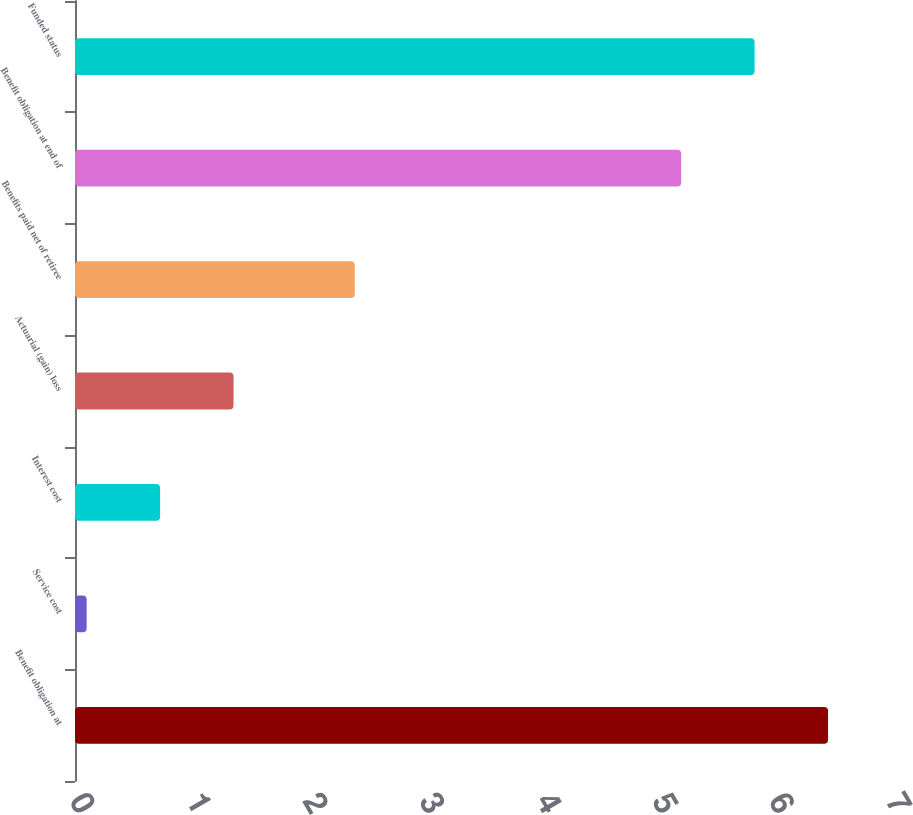Convert chart to OTSL. <chart><loc_0><loc_0><loc_500><loc_500><bar_chart><fcel>Benefit obligation at<fcel>Service cost<fcel>Interest cost<fcel>Actuarial (gain) loss<fcel>Benefits paid net of retiree<fcel>Benefit obligation at end of<fcel>Funded status<nl><fcel>6.46<fcel>0.1<fcel>0.73<fcel>1.36<fcel>2.4<fcel>5.2<fcel>5.83<nl></chart> 